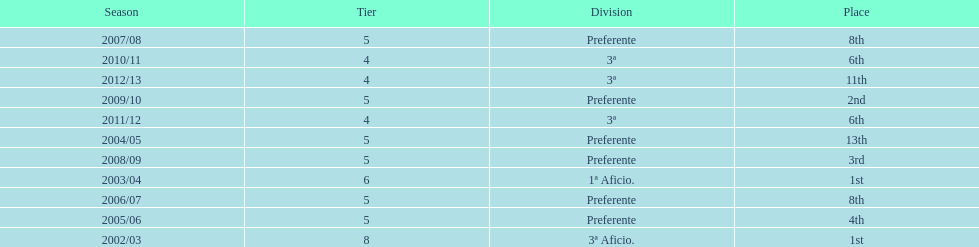How many seasons did internacional de madrid cf play in the preferente division? 6. 